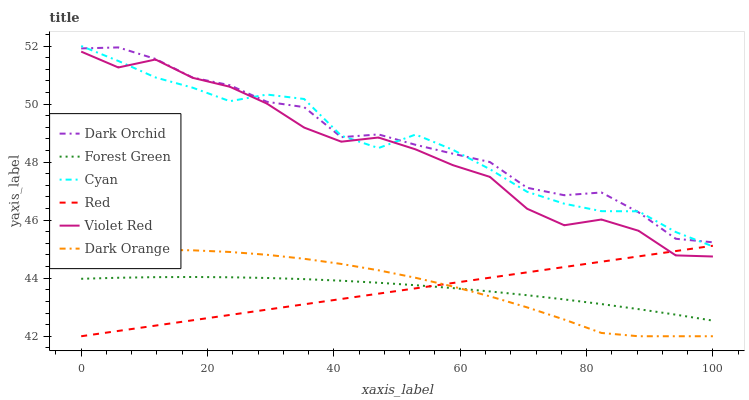Does Red have the minimum area under the curve?
Answer yes or no. Yes. Does Dark Orchid have the maximum area under the curve?
Answer yes or no. Yes. Does Violet Red have the minimum area under the curve?
Answer yes or no. No. Does Violet Red have the maximum area under the curve?
Answer yes or no. No. Is Red the smoothest?
Answer yes or no. Yes. Is Violet Red the roughest?
Answer yes or no. Yes. Is Dark Orchid the smoothest?
Answer yes or no. No. Is Dark Orchid the roughest?
Answer yes or no. No. Does Violet Red have the lowest value?
Answer yes or no. No. Does Cyan have the highest value?
Answer yes or no. Yes. Does Violet Red have the highest value?
Answer yes or no. No. Is Red less than Dark Orchid?
Answer yes or no. Yes. Is Violet Red greater than Forest Green?
Answer yes or no. Yes. Does Forest Green intersect Red?
Answer yes or no. Yes. Is Forest Green less than Red?
Answer yes or no. No. Is Forest Green greater than Red?
Answer yes or no. No. Does Red intersect Dark Orchid?
Answer yes or no. No. 